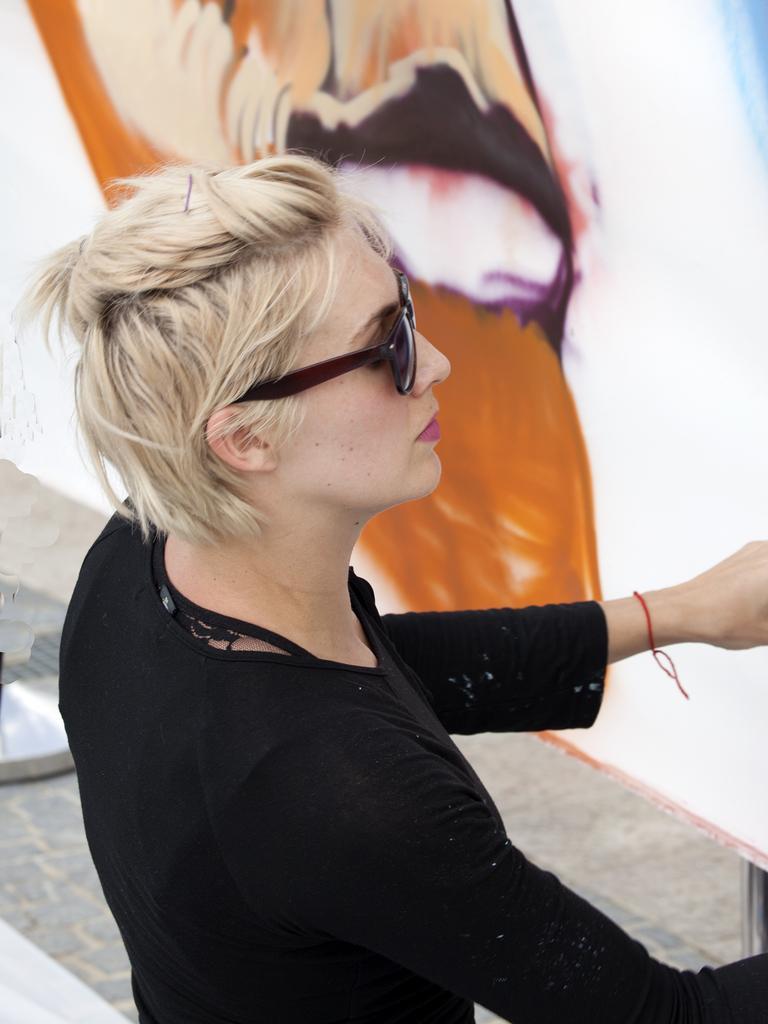In one or two sentences, can you explain what this image depicts? In this picture I can see a woman in the middle, she is wearing a black color dress. At the top it looks like a painting. 